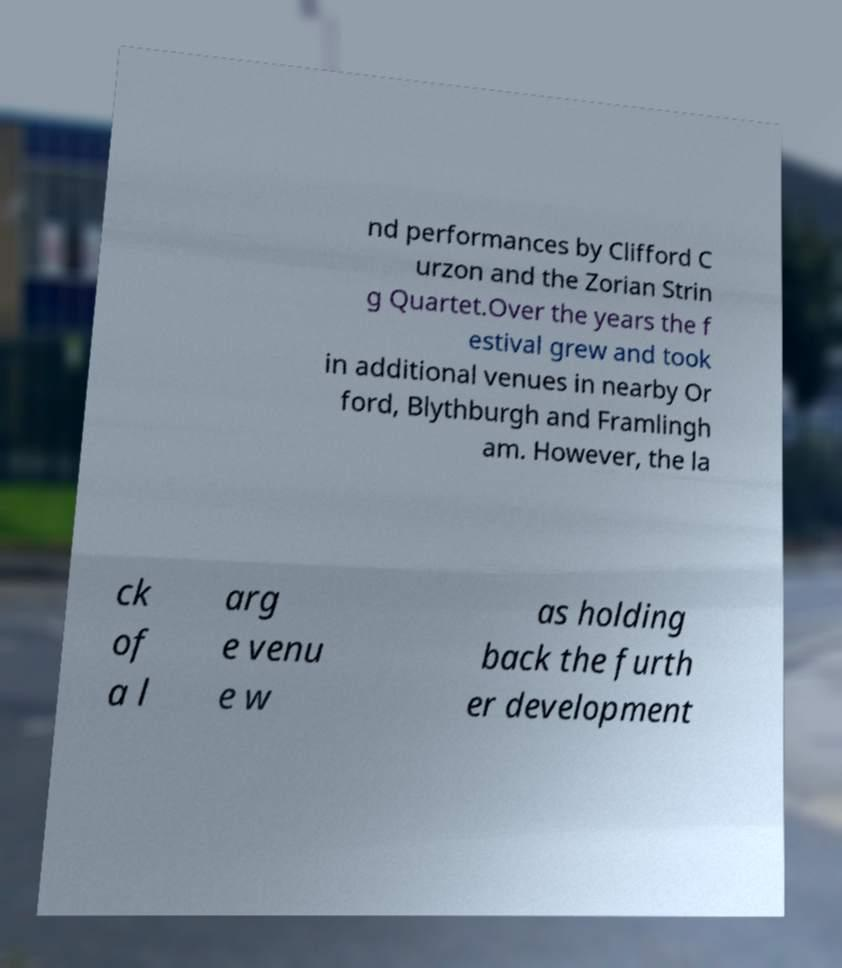Could you extract and type out the text from this image? nd performances by Clifford C urzon and the Zorian Strin g Quartet.Over the years the f estival grew and took in additional venues in nearby Or ford, Blythburgh and Framlingh am. However, the la ck of a l arg e venu e w as holding back the furth er development 